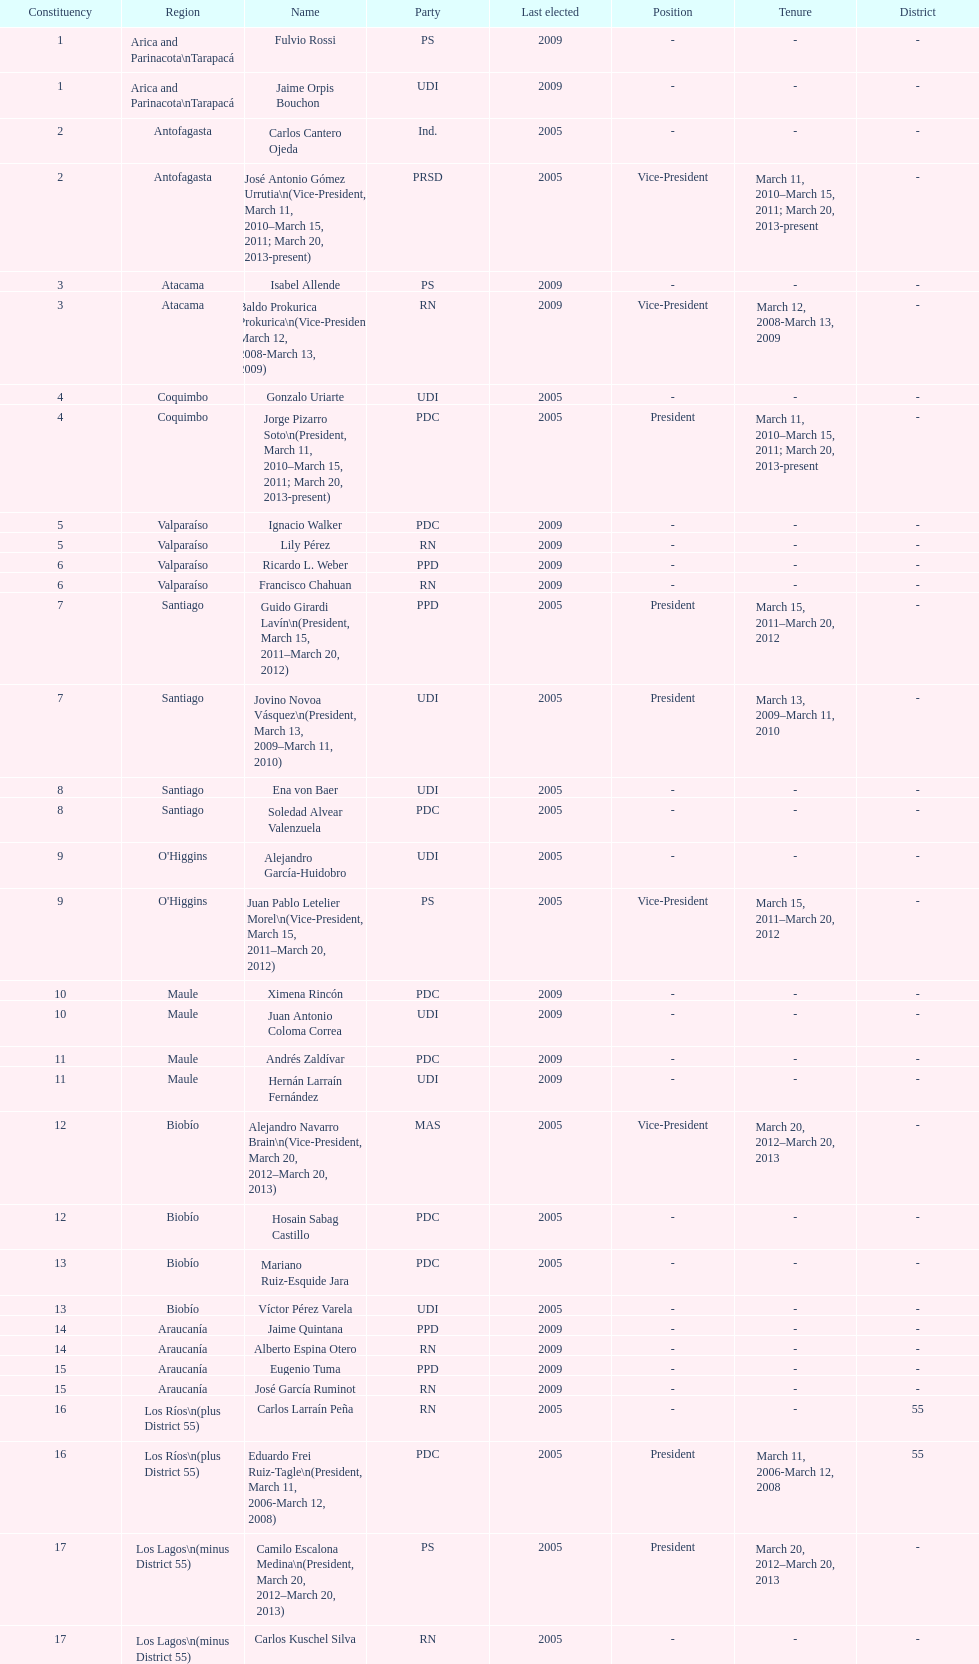When was antonio horvath kiss last elected? 2001. 